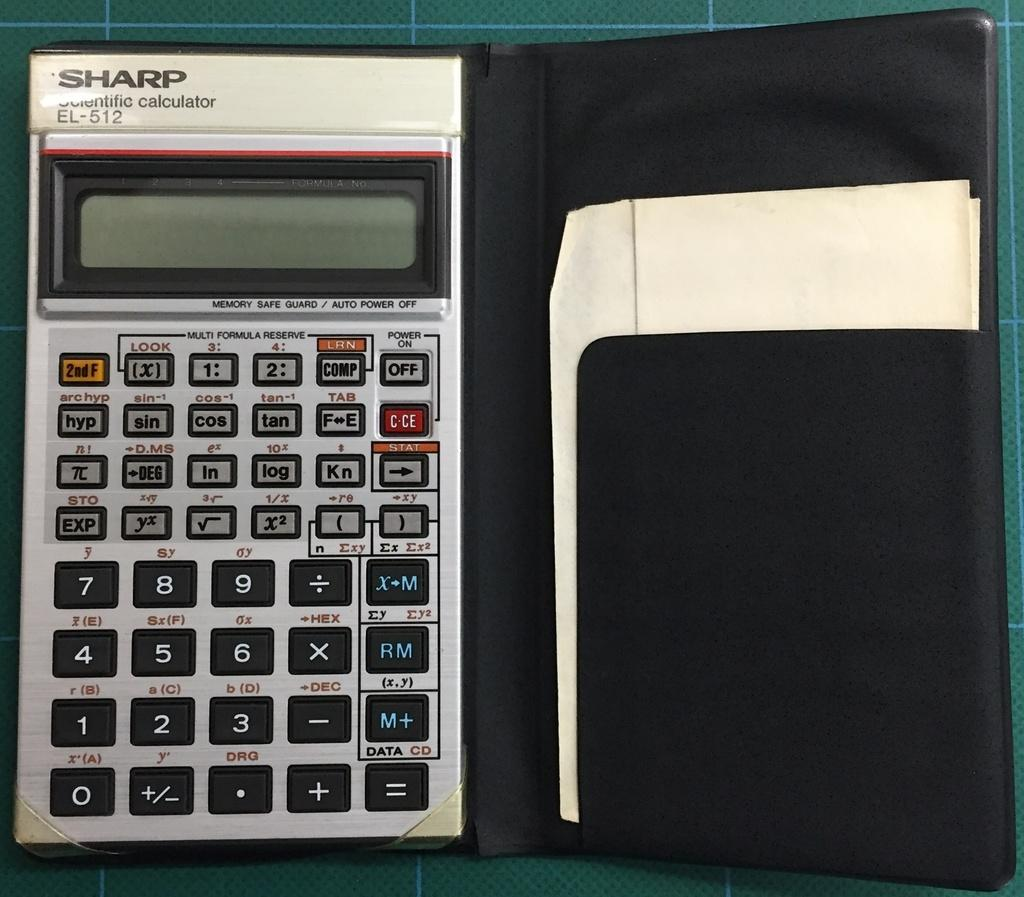Provide a one-sentence caption for the provided image. A Sharp scientific calculator is in a black case with a piece of paper in its side pocket. 